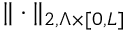Convert formula to latex. <formula><loc_0><loc_0><loc_500><loc_500>\| \cdot \| _ { 2 , \Lambda \times [ 0 , L ] }</formula> 